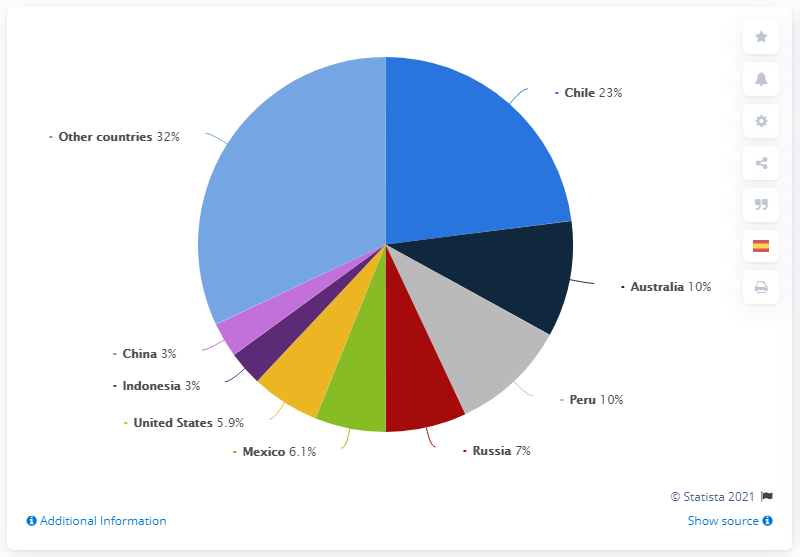Indicate a few pertinent items in this graphic. Eight countries are considered (except for others). Peru has approximately 10% of the world's total copper reserves, making it a significant global producer of this valuable metal. Australia has a smaller population than Peru, with a ratio of approximately 1 to 1. In 2019, Chile had approximately 23% of the global copper reserves. In 2019, Chile was the country with the largest reserves of copper. 